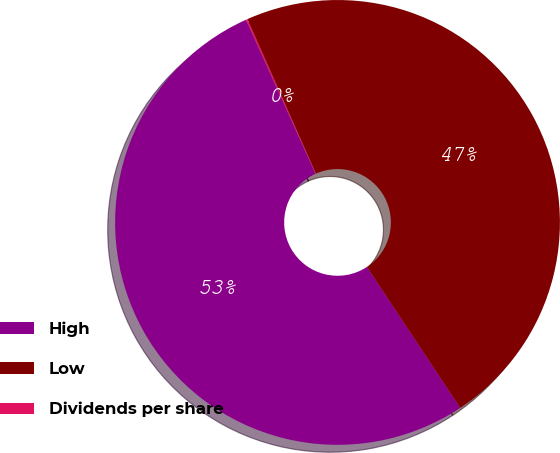Convert chart. <chart><loc_0><loc_0><loc_500><loc_500><pie_chart><fcel>High<fcel>Low<fcel>Dividends per share<nl><fcel>52.55%<fcel>47.34%<fcel>0.11%<nl></chart> 